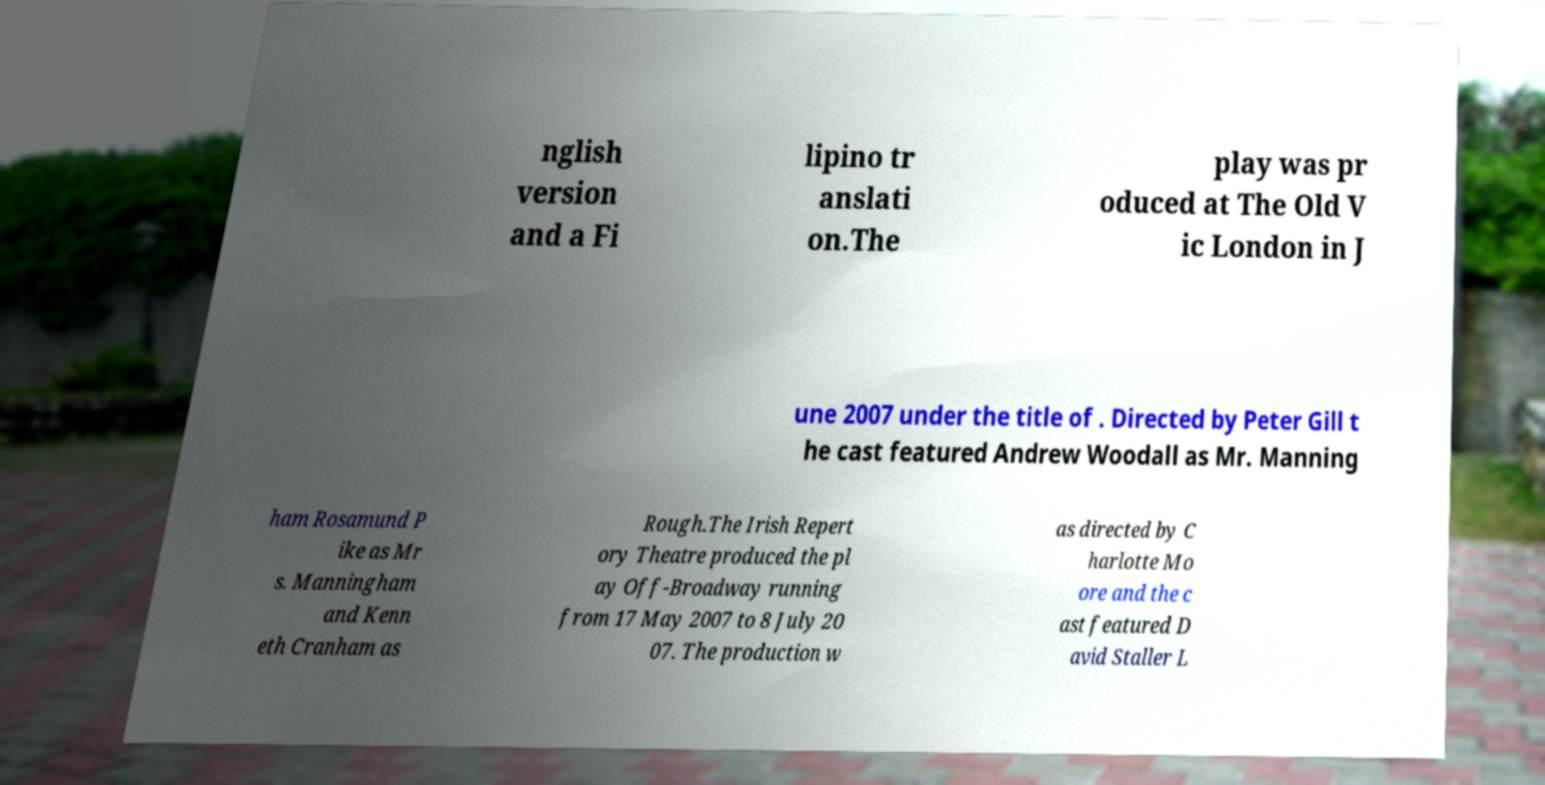For documentation purposes, I need the text within this image transcribed. Could you provide that? nglish version and a Fi lipino tr anslati on.The play was pr oduced at The Old V ic London in J une 2007 under the title of . Directed by Peter Gill t he cast featured Andrew Woodall as Mr. Manning ham Rosamund P ike as Mr s. Manningham and Kenn eth Cranham as Rough.The Irish Repert ory Theatre produced the pl ay Off-Broadway running from 17 May 2007 to 8 July 20 07. The production w as directed by C harlotte Mo ore and the c ast featured D avid Staller L 